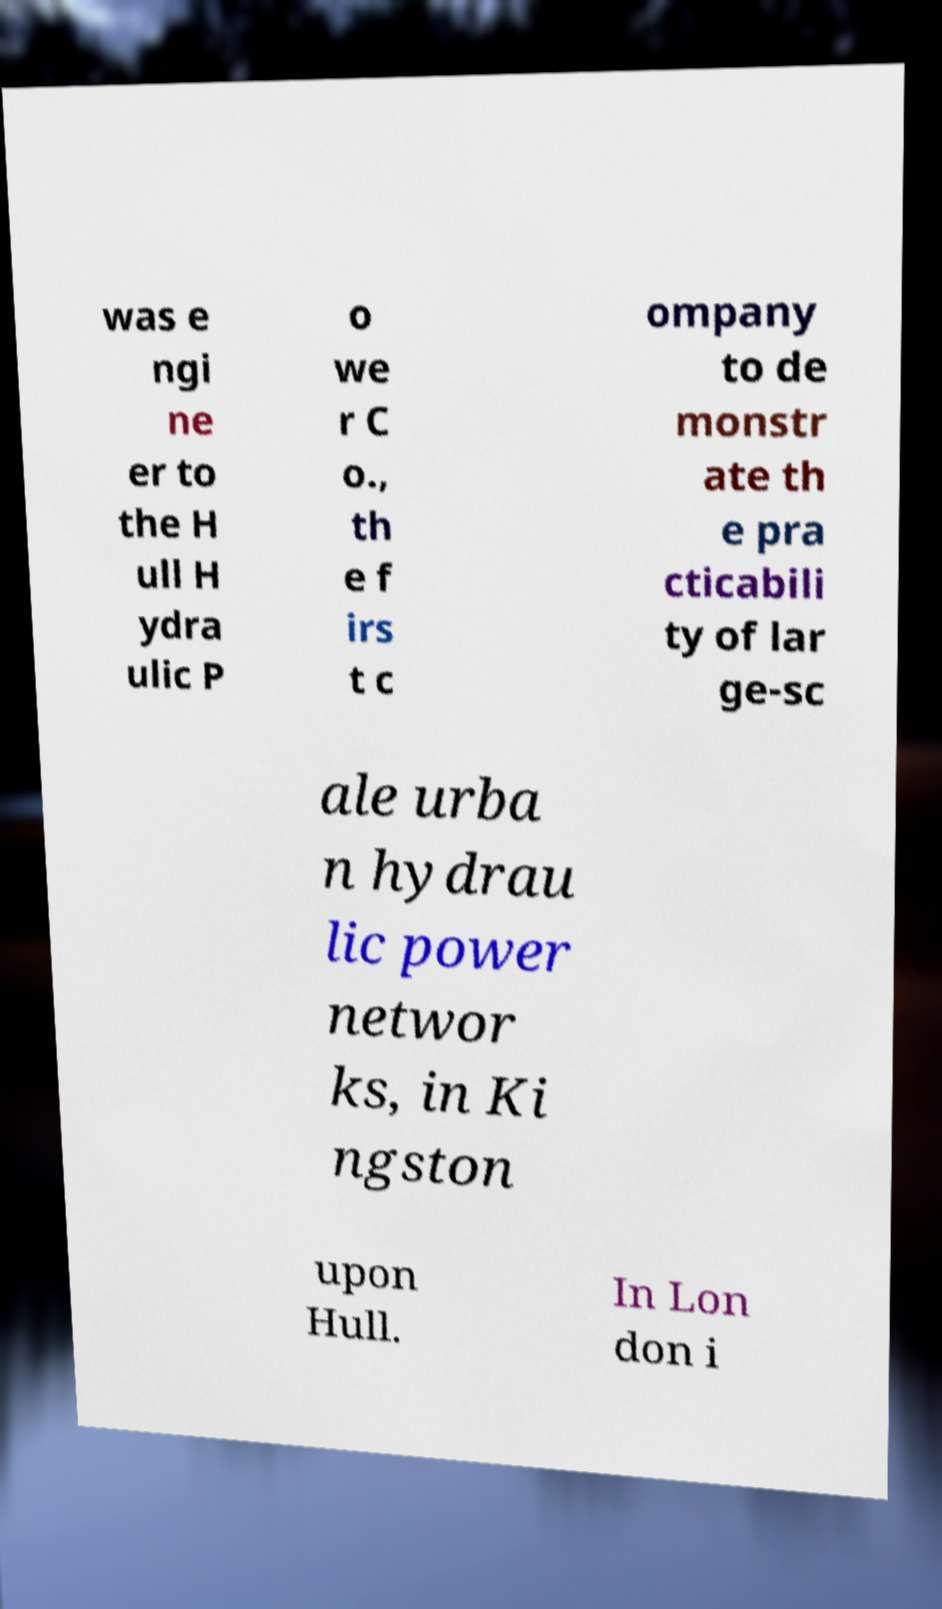For documentation purposes, I need the text within this image transcribed. Could you provide that? was e ngi ne er to the H ull H ydra ulic P o we r C o., th e f irs t c ompany to de monstr ate th e pra cticabili ty of lar ge-sc ale urba n hydrau lic power networ ks, in Ki ngston upon Hull. In Lon don i 